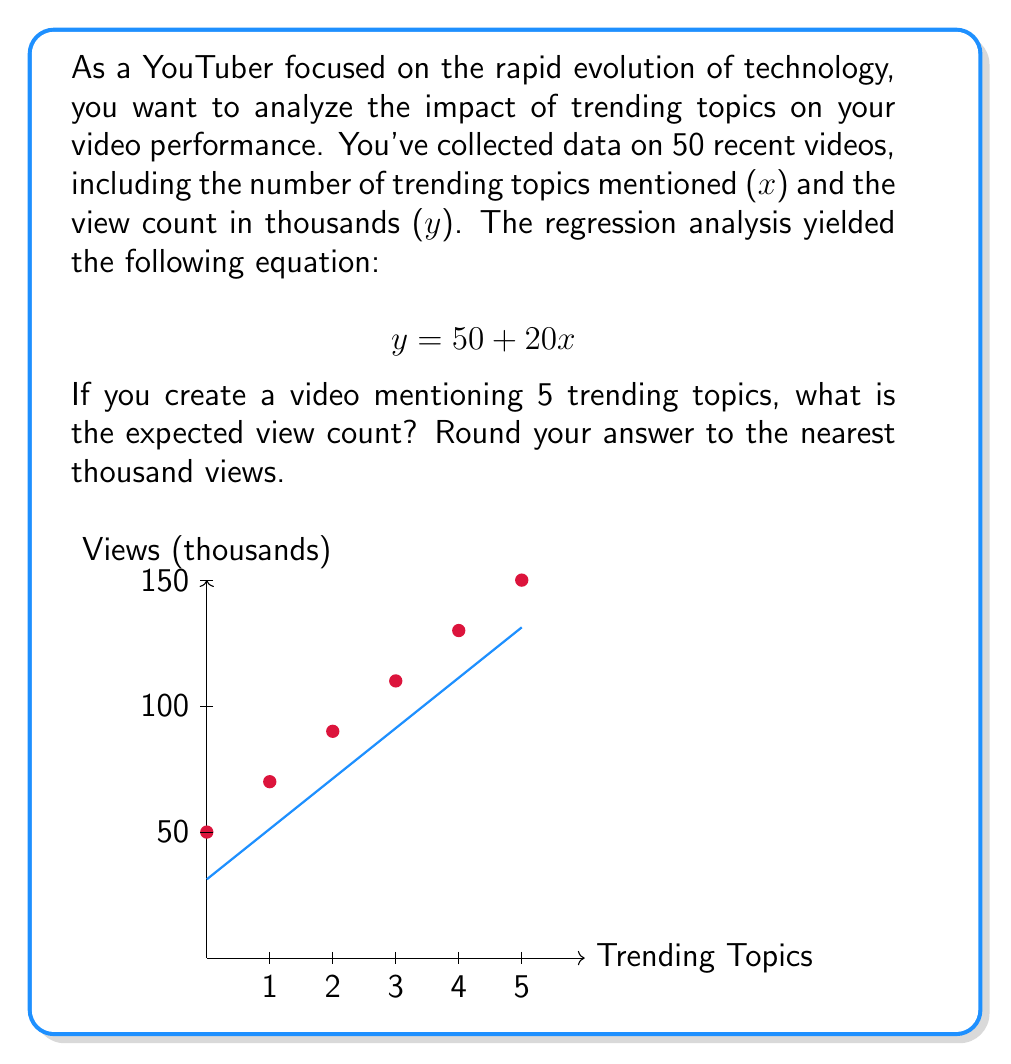Show me your answer to this math problem. Let's approach this step-by-step:

1) The regression equation is given as:
   $$ y = 50 + 20x $$
   Where y is the view count in thousands, and x is the number of trending topics mentioned.

2) We want to find the expected view count when x = 5 (5 trending topics mentioned).

3) Let's substitute x = 5 into the equation:
   $$ y = 50 + 20(5) $$

4) Simplify:
   $$ y = 50 + 100 = 150 $$

5) Interpret the result:
   The expected view count is 150 thousand views, or 150,000 views.

6) The question asks to round to the nearest thousand, but 150,000 is already in thousands, so no further rounding is needed.

This result aligns with the graph, where we can see the line passing through the point (5, 150).
Answer: 150,000 views 